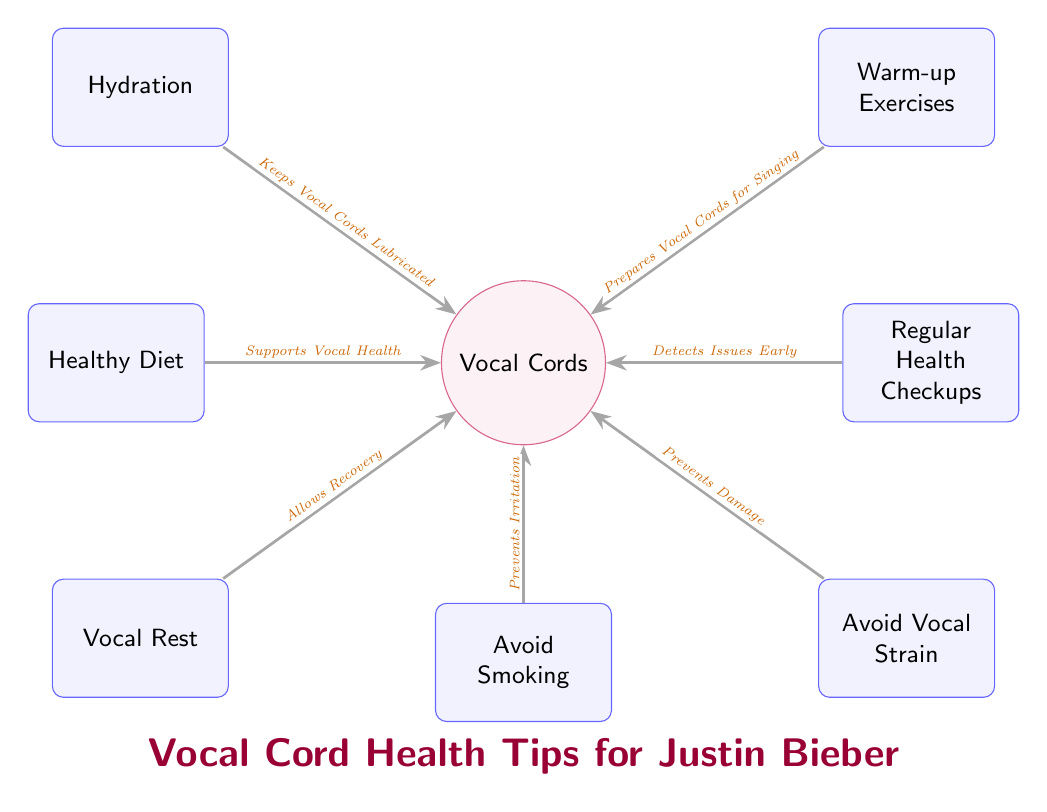What are the main components that support vocal cord health? The diagram lists seven components: Hydration, Warm-up Exercises, Vocal Rest, Healthy Diet, Regular Health Checkups, Avoid Vocal Strain, and Avoid Smoking, all of which are linked directly to the Vocal Cords.
Answer: Hydration, Warm-up Exercises, Vocal Rest, Healthy Diet, Regular Health Checkups, Avoid Vocal Strain, Avoid Smoking How many tips are provided for maintaining vocal cord health? The diagram contains a total of seven tips arranged around the Vocal Cords. Each tip is represented as a node connected to the main node, Vocal Cords.
Answer: Seven What does hydration do for vocal cords? The diagram states that Hydration "Keeps Vocal Cords Lubricated," indicating its role in maintaining healthy vocal cords.
Answer: Keeps Vocal Cords Lubricated Which tip is related to recovery for vocal cords? Vocal Rest is indicated in the diagram, and its connection to the Vocal Cords shows that it "Allows Recovery," making it the related tip for recovery.
Answer: Vocal Rest What precaution is suggested to prevent irritation? According to the diagram, the tip to "Avoid Smoking" is aimed at preventing irritation in the vocal cords, making it clear that smoking is detrimental to their health.
Answer: Avoid Smoking How do warm-up exercises benefit vocal cords? The diagram specifies that Warm-up Exercises "Prepares Vocal Cords for Singing," showing their importance in preparing the vocal cords before using them extensively.
Answer: Prepares Vocal Cords for Singing What relationship does a healthy diet have with vocal health? The Healthy Diet node in the diagram is connected to the Vocal Cords with the label "Supports Vocal Health," indicating that a balanced diet is beneficial for maintaining vocal health.
Answer: Supports Vocal Health Which tip is connected to early issue detection? The diagram depicts Regular Health Checkups and states that they "Detects Issues Early," highlighting its significance in proactive health maintenance for singers.
Answer: Regular Health Checkups 